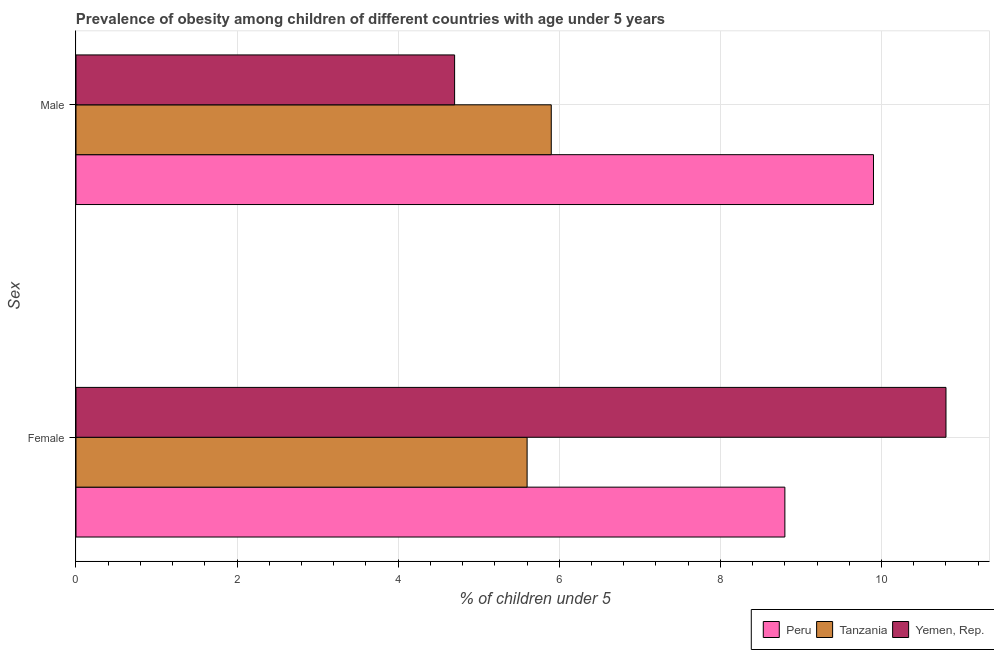Are the number of bars per tick equal to the number of legend labels?
Provide a short and direct response. Yes. How many bars are there on the 2nd tick from the top?
Give a very brief answer. 3. How many bars are there on the 2nd tick from the bottom?
Make the answer very short. 3. What is the percentage of obese female children in Tanzania?
Provide a succinct answer. 5.6. Across all countries, what is the maximum percentage of obese male children?
Your answer should be compact. 9.9. Across all countries, what is the minimum percentage of obese male children?
Provide a short and direct response. 4.7. In which country was the percentage of obese female children maximum?
Provide a succinct answer. Yemen, Rep. In which country was the percentage of obese male children minimum?
Make the answer very short. Yemen, Rep. What is the total percentage of obese male children in the graph?
Offer a terse response. 20.5. What is the difference between the percentage of obese female children in Tanzania and that in Yemen, Rep.?
Offer a very short reply. -5.2. What is the difference between the percentage of obese male children in Yemen, Rep. and the percentage of obese female children in Peru?
Keep it short and to the point. -4.1. What is the average percentage of obese female children per country?
Provide a short and direct response. 8.4. What is the difference between the percentage of obese female children and percentage of obese male children in Yemen, Rep.?
Your response must be concise. 6.1. In how many countries, is the percentage of obese female children greater than 7.6 %?
Offer a very short reply. 2. What is the ratio of the percentage of obese female children in Tanzania to that in Peru?
Your response must be concise. 0.64. In how many countries, is the percentage of obese female children greater than the average percentage of obese female children taken over all countries?
Your response must be concise. 2. What does the 2nd bar from the top in Male represents?
Offer a very short reply. Tanzania. How many bars are there?
Keep it short and to the point. 6. Are all the bars in the graph horizontal?
Offer a very short reply. Yes. How many countries are there in the graph?
Give a very brief answer. 3. Does the graph contain any zero values?
Give a very brief answer. No. How many legend labels are there?
Offer a terse response. 3. How are the legend labels stacked?
Make the answer very short. Horizontal. What is the title of the graph?
Keep it short and to the point. Prevalence of obesity among children of different countries with age under 5 years. Does "Iceland" appear as one of the legend labels in the graph?
Your answer should be very brief. No. What is the label or title of the X-axis?
Make the answer very short.  % of children under 5. What is the label or title of the Y-axis?
Offer a very short reply. Sex. What is the  % of children under 5 in Peru in Female?
Provide a short and direct response. 8.8. What is the  % of children under 5 of Tanzania in Female?
Your answer should be very brief. 5.6. What is the  % of children under 5 in Yemen, Rep. in Female?
Provide a succinct answer. 10.8. What is the  % of children under 5 in Peru in Male?
Ensure brevity in your answer.  9.9. What is the  % of children under 5 of Tanzania in Male?
Provide a short and direct response. 5.9. What is the  % of children under 5 of Yemen, Rep. in Male?
Your response must be concise. 4.7. Across all Sex, what is the maximum  % of children under 5 of Peru?
Give a very brief answer. 9.9. Across all Sex, what is the maximum  % of children under 5 of Tanzania?
Offer a terse response. 5.9. Across all Sex, what is the maximum  % of children under 5 of Yemen, Rep.?
Provide a succinct answer. 10.8. Across all Sex, what is the minimum  % of children under 5 of Peru?
Give a very brief answer. 8.8. Across all Sex, what is the minimum  % of children under 5 in Tanzania?
Your answer should be compact. 5.6. Across all Sex, what is the minimum  % of children under 5 in Yemen, Rep.?
Keep it short and to the point. 4.7. What is the total  % of children under 5 of Tanzania in the graph?
Provide a succinct answer. 11.5. What is the difference between the  % of children under 5 in Peru in Female and that in Male?
Keep it short and to the point. -1.1. What is the difference between the  % of children under 5 in Tanzania in Female and that in Male?
Give a very brief answer. -0.3. What is the difference between the  % of children under 5 of Yemen, Rep. in Female and that in Male?
Provide a succinct answer. 6.1. What is the difference between the  % of children under 5 of Peru in Female and the  % of children under 5 of Tanzania in Male?
Provide a succinct answer. 2.9. What is the difference between the  % of children under 5 of Tanzania in Female and the  % of children under 5 of Yemen, Rep. in Male?
Keep it short and to the point. 0.9. What is the average  % of children under 5 of Peru per Sex?
Ensure brevity in your answer.  9.35. What is the average  % of children under 5 of Tanzania per Sex?
Give a very brief answer. 5.75. What is the average  % of children under 5 of Yemen, Rep. per Sex?
Provide a short and direct response. 7.75. What is the difference between the  % of children under 5 in Peru and  % of children under 5 in Tanzania in Female?
Make the answer very short. 3.2. What is the difference between the  % of children under 5 in Peru and  % of children under 5 in Yemen, Rep. in Female?
Provide a short and direct response. -2. What is the difference between the  % of children under 5 of Peru and  % of children under 5 of Tanzania in Male?
Your answer should be very brief. 4. What is the ratio of the  % of children under 5 of Peru in Female to that in Male?
Provide a short and direct response. 0.89. What is the ratio of the  % of children under 5 of Tanzania in Female to that in Male?
Your answer should be very brief. 0.95. What is the ratio of the  % of children under 5 of Yemen, Rep. in Female to that in Male?
Your answer should be compact. 2.3. What is the difference between the highest and the second highest  % of children under 5 of Peru?
Your response must be concise. 1.1. What is the difference between the highest and the second highest  % of children under 5 of Tanzania?
Make the answer very short. 0.3. What is the difference between the highest and the second highest  % of children under 5 in Yemen, Rep.?
Provide a succinct answer. 6.1. What is the difference between the highest and the lowest  % of children under 5 of Peru?
Your answer should be compact. 1.1. What is the difference between the highest and the lowest  % of children under 5 of Tanzania?
Your answer should be very brief. 0.3. 